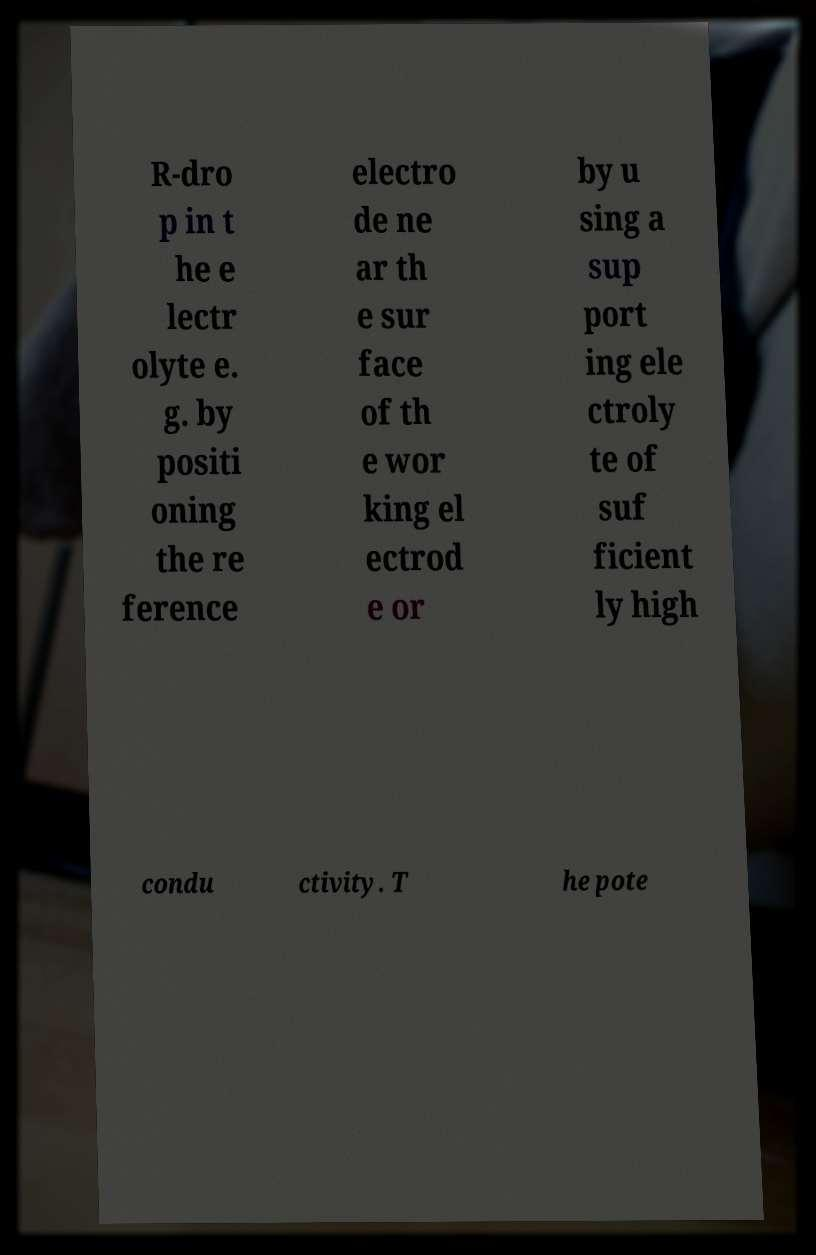Can you read and provide the text displayed in the image?This photo seems to have some interesting text. Can you extract and type it out for me? R-dro p in t he e lectr olyte e. g. by positi oning the re ference electro de ne ar th e sur face of th e wor king el ectrod e or by u sing a sup port ing ele ctroly te of suf ficient ly high condu ctivity. T he pote 